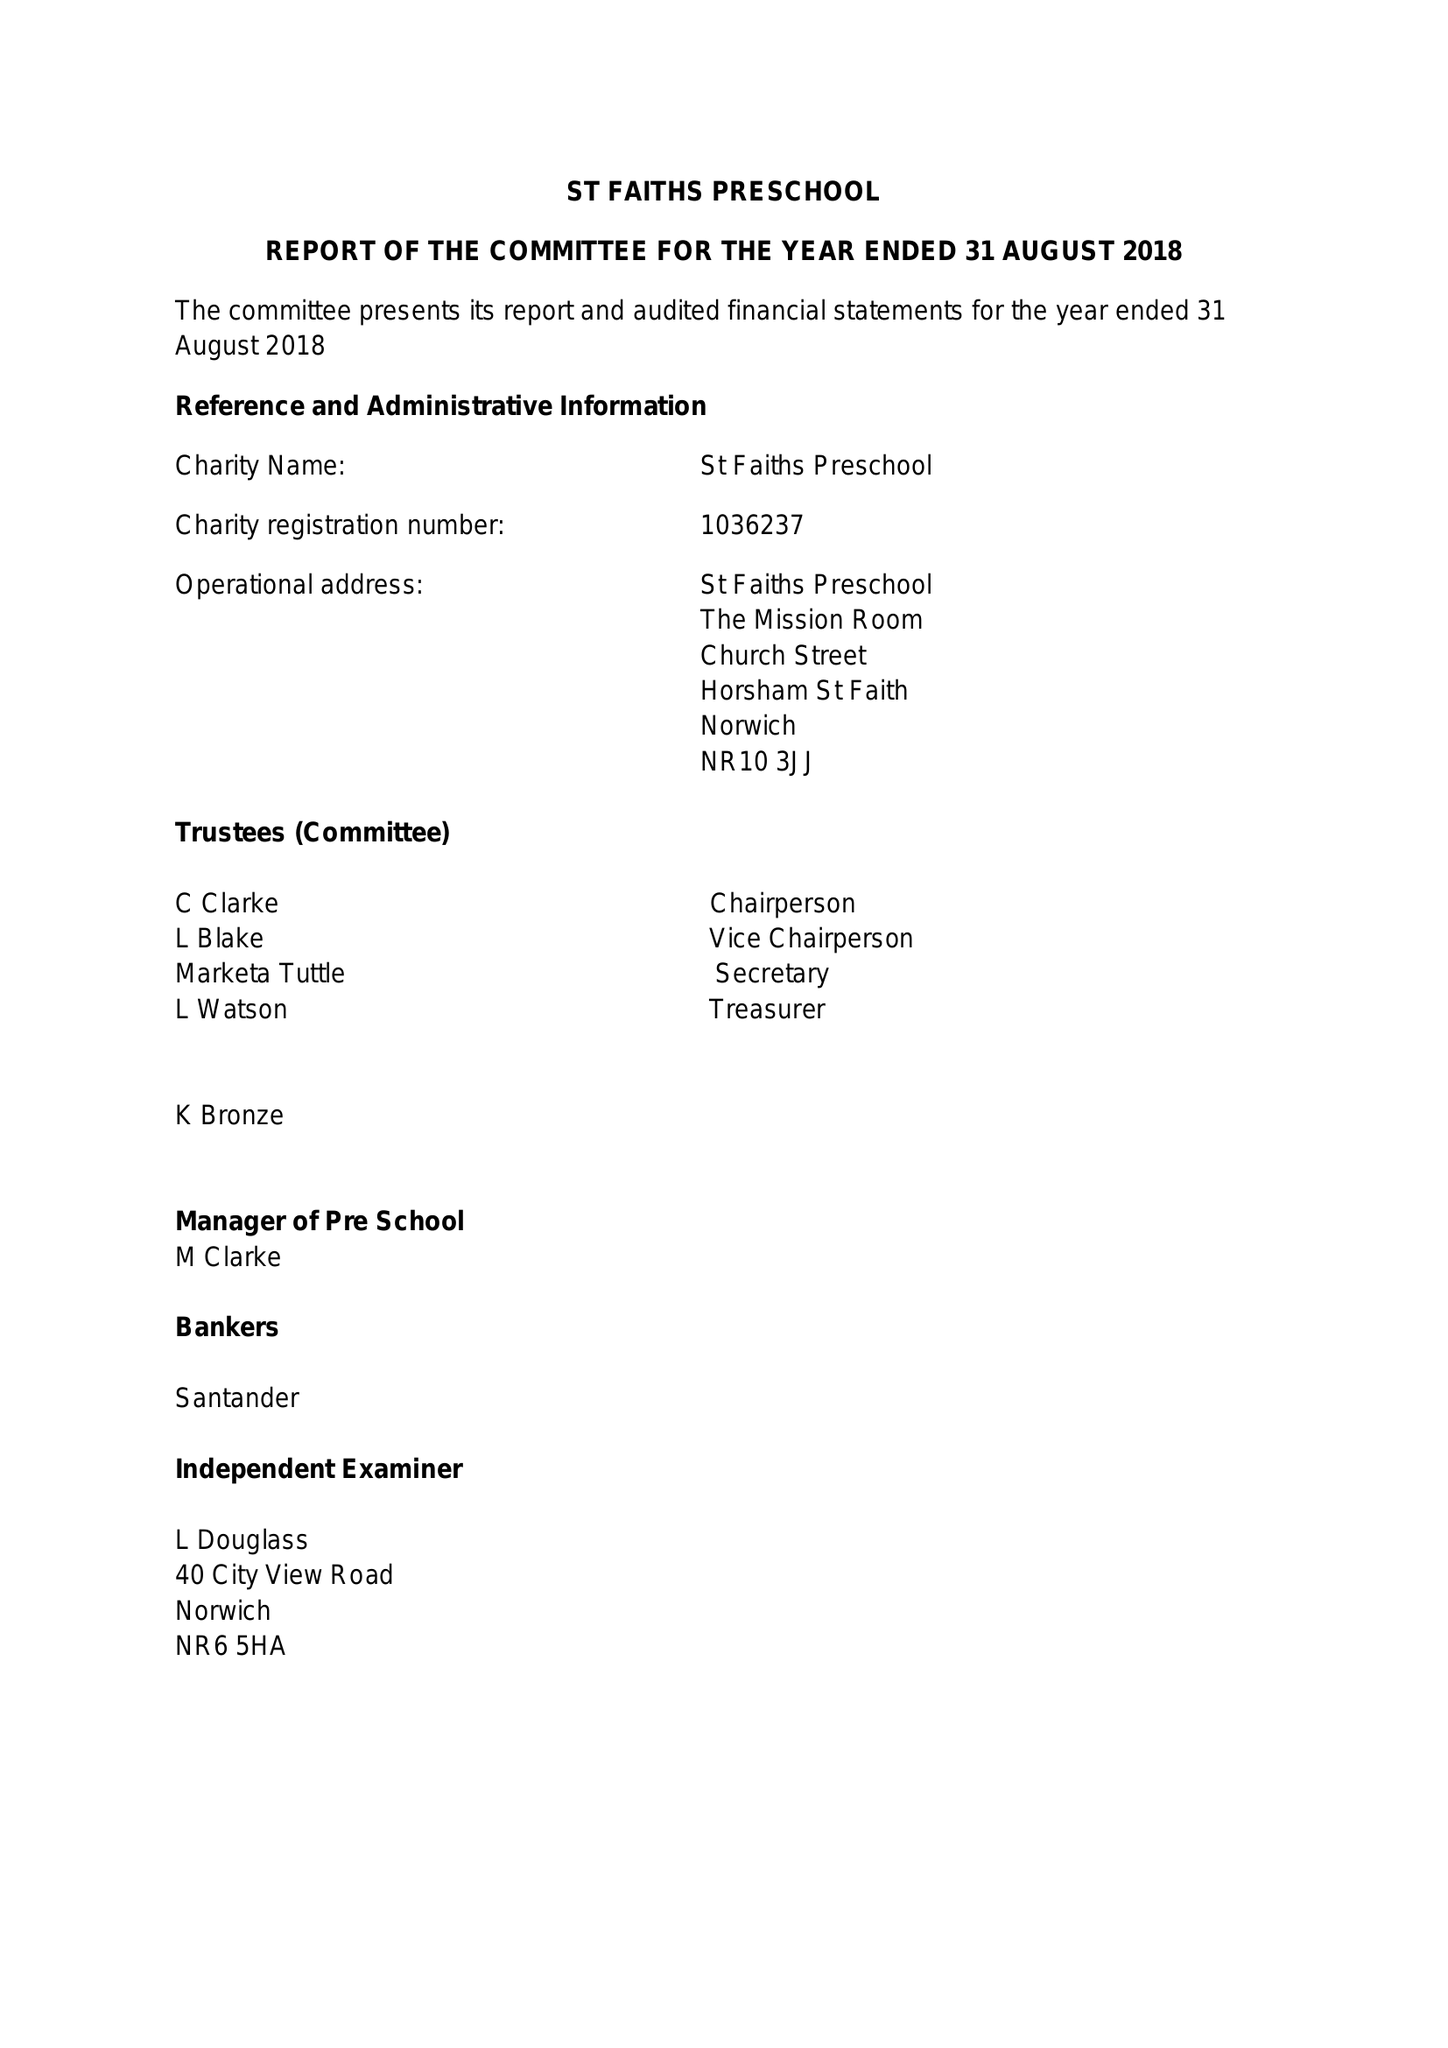What is the value for the address__postcode?
Answer the question using a single word or phrase. NR10 3JJ 